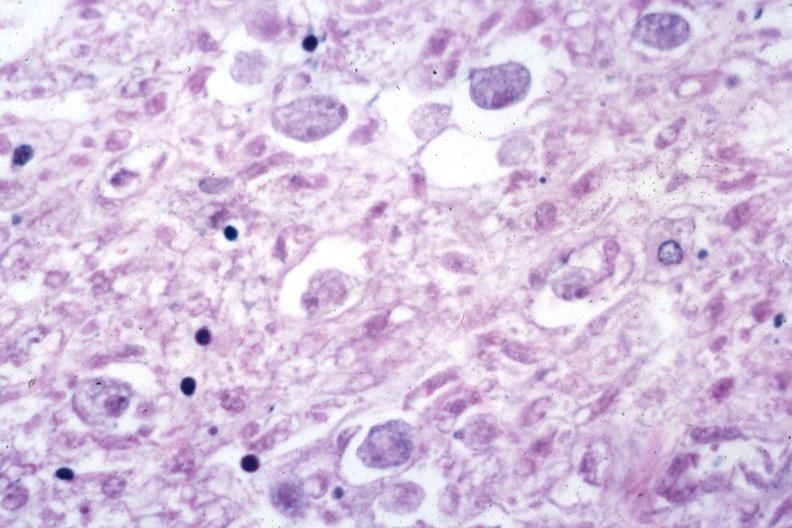s angiogram saphenous vein bypass graft present?
Answer the question using a single word or phrase. No 